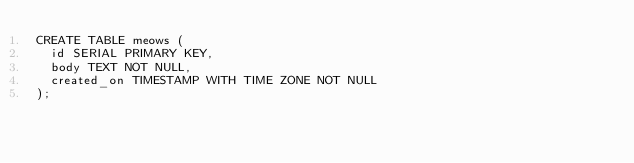Convert code to text. <code><loc_0><loc_0><loc_500><loc_500><_SQL_>CREATE TABLE meows (
  id SERIAL PRIMARY KEY,
  body TEXT NOT NULL,
  created_on TIMESTAMP WITH TIME ZONE NOT NULL
);</code> 